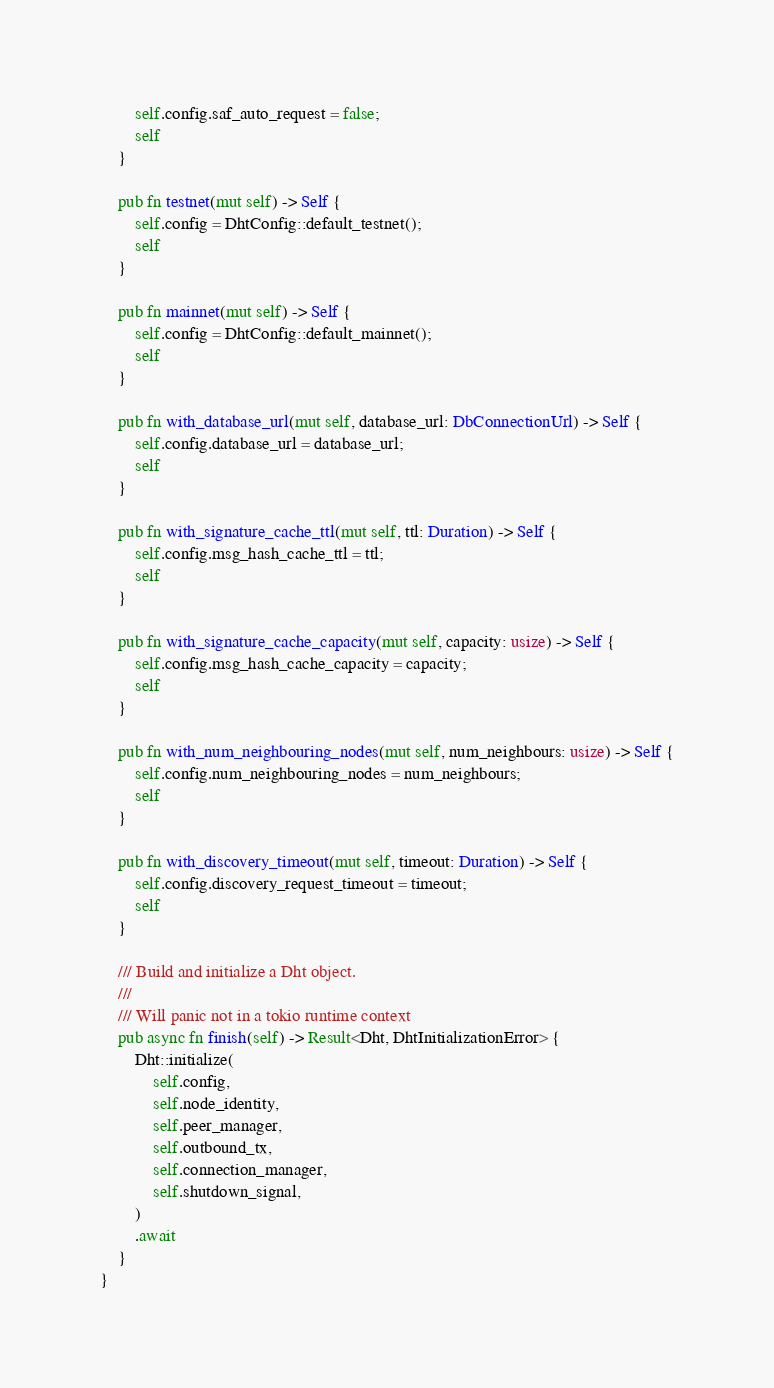<code> <loc_0><loc_0><loc_500><loc_500><_Rust_>        self.config.saf_auto_request = false;
        self
    }

    pub fn testnet(mut self) -> Self {
        self.config = DhtConfig::default_testnet();
        self
    }

    pub fn mainnet(mut self) -> Self {
        self.config = DhtConfig::default_mainnet();
        self
    }

    pub fn with_database_url(mut self, database_url: DbConnectionUrl) -> Self {
        self.config.database_url = database_url;
        self
    }

    pub fn with_signature_cache_ttl(mut self, ttl: Duration) -> Self {
        self.config.msg_hash_cache_ttl = ttl;
        self
    }

    pub fn with_signature_cache_capacity(mut self, capacity: usize) -> Self {
        self.config.msg_hash_cache_capacity = capacity;
        self
    }

    pub fn with_num_neighbouring_nodes(mut self, num_neighbours: usize) -> Self {
        self.config.num_neighbouring_nodes = num_neighbours;
        self
    }

    pub fn with_discovery_timeout(mut self, timeout: Duration) -> Self {
        self.config.discovery_request_timeout = timeout;
        self
    }

    /// Build and initialize a Dht object.
    ///
    /// Will panic not in a tokio runtime context
    pub async fn finish(self) -> Result<Dht, DhtInitializationError> {
        Dht::initialize(
            self.config,
            self.node_identity,
            self.peer_manager,
            self.outbound_tx,
            self.connection_manager,
            self.shutdown_signal,
        )
        .await
    }
}
</code> 